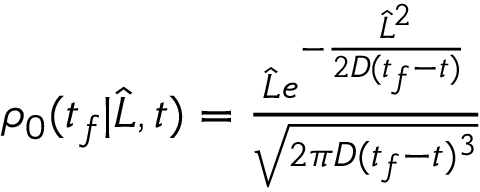<formula> <loc_0><loc_0><loc_500><loc_500>\begin{array} { r } { \rho _ { 0 } ( t _ { f } | \widehat { L } , t ) = \frac { \widehat { L } e ^ { - \frac { \widehat { L } ^ { 2 } } { 2 D ( t _ { f } - t ) } } } { \sqrt { 2 \pi D ( t _ { f } - t ) ^ { 3 } } } } \end{array}</formula> 